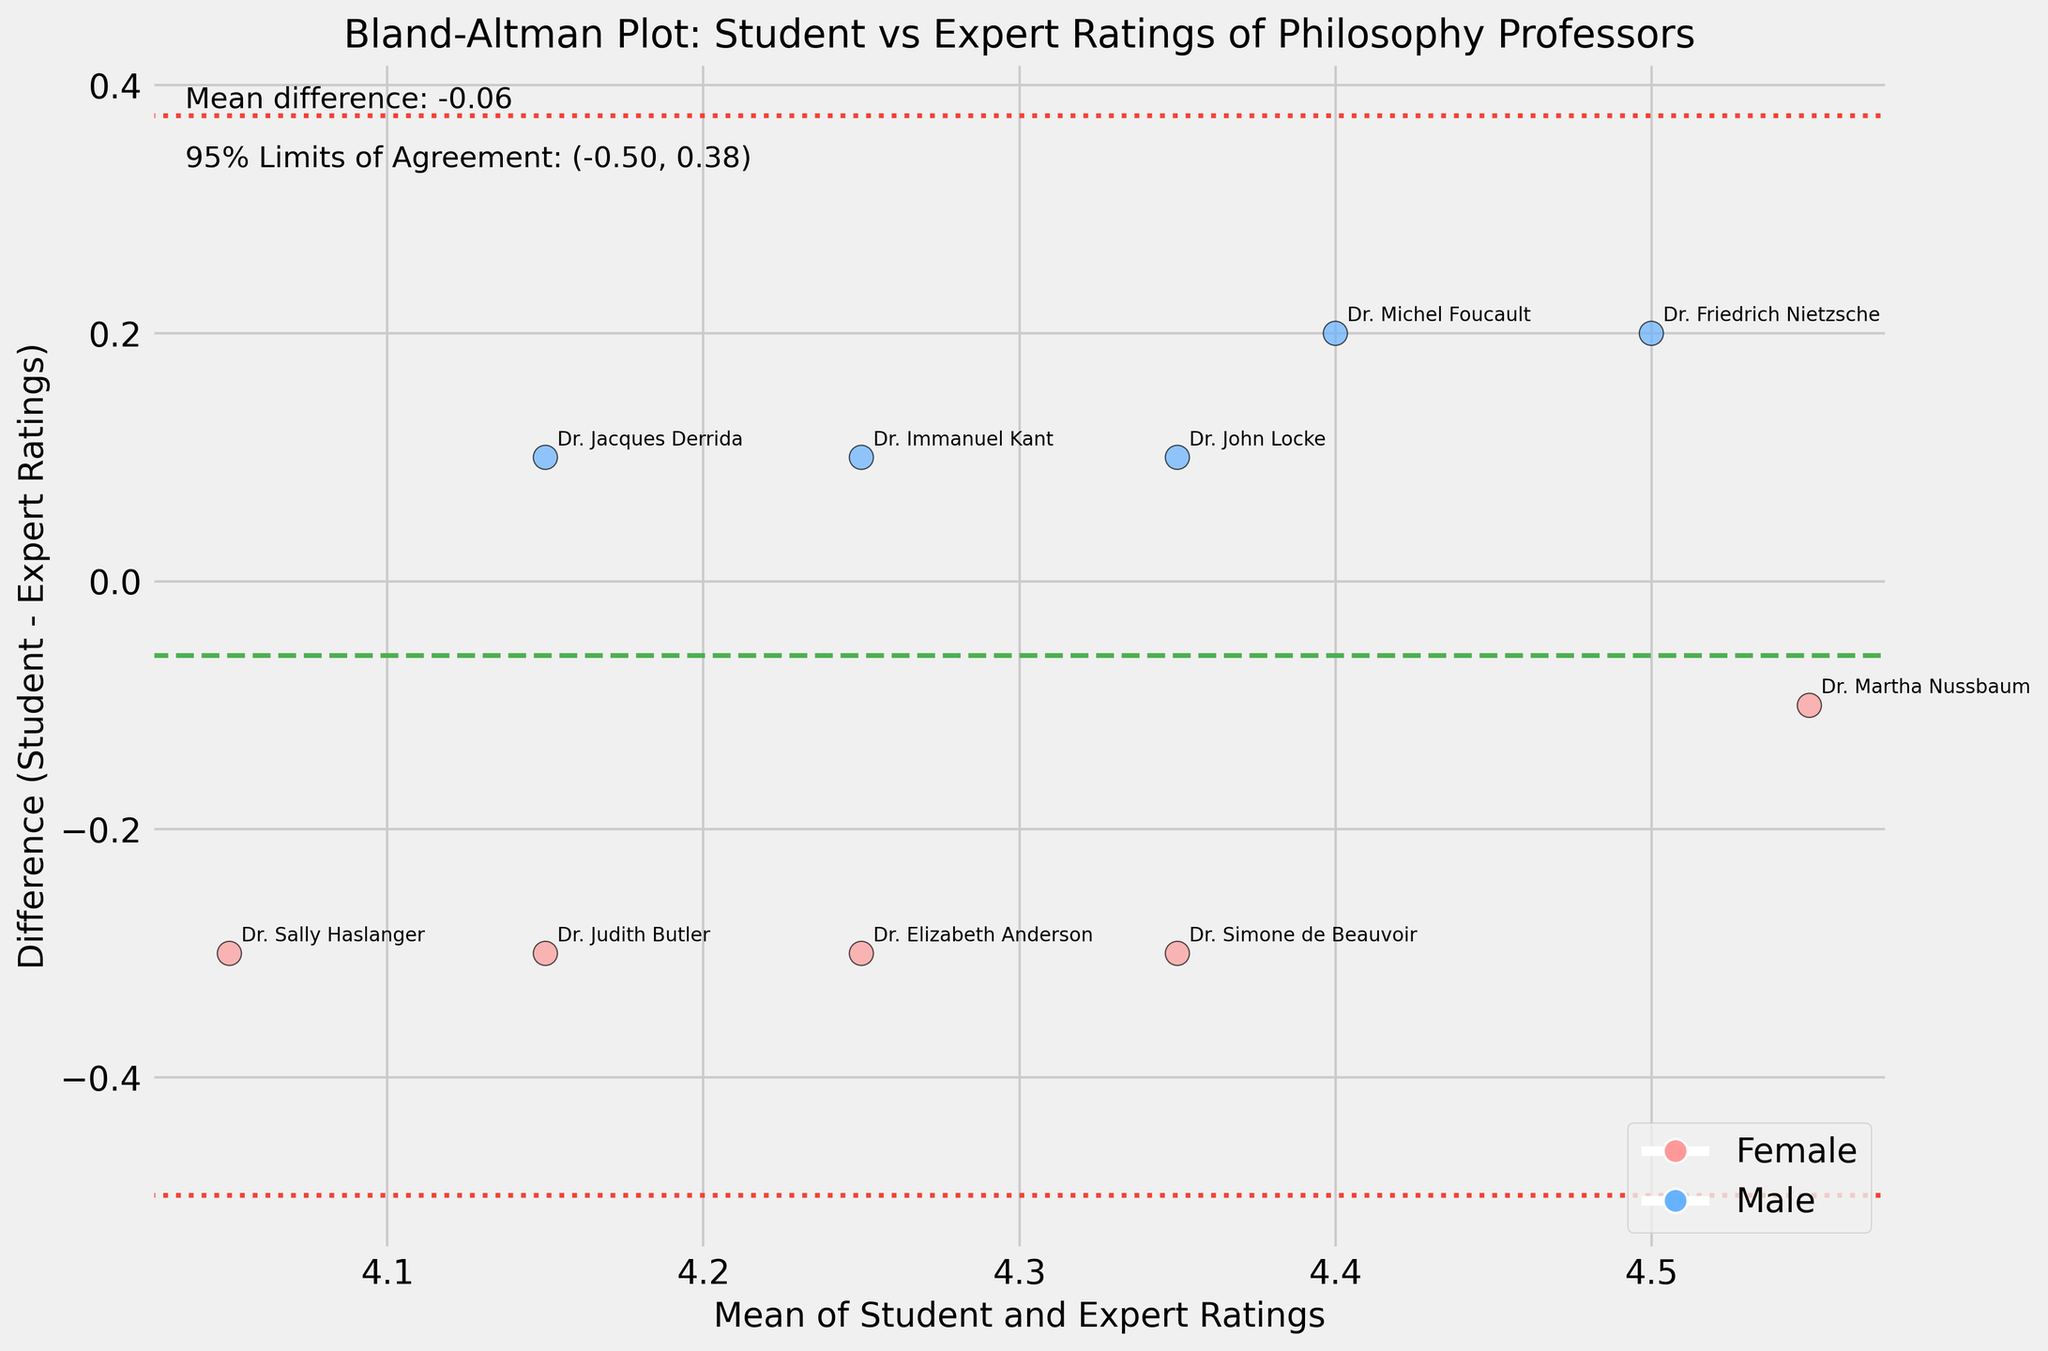What is the title of the plot? The title is displayed at the top center of the plot. It reads: "Bland-Altman Plot: Student vs Expert Ratings of Philosophy Professors".
Answer: Bland-Altman Plot: Student vs Expert Ratings of Philosophy Professors How many data points are displayed in the plot? Each data point represents an instructor. There are 10 distinct scatter points, each labeled with an instructor's name.
Answer: 10 What color represents female instructors in the plot? The scatter points for female instructors are colored in a light red (pink) shade, as indicated by the legend.
Answer: Pink Which instructor has the smallest difference between student and expert ratings? The smallest difference can be found by looking for the data point closest to the zero horizontal (mean difference) line. Dr. Martha Nussbaum (Female) has a difference close to zero.
Answer: Dr. Martha Nussbaum What is the mean difference between student and expert ratings? The mean difference is indicated by the horizontal dashed green line, labeled as "Mean difference: 0.10" in the text on the plot.
Answer: 0.10 Which instructor has the largest positive difference between student and expert ratings? The largest positive difference is found by locating the data point farthest above the zero line. Dr. Friedrich Nietzsche (Male) has the largest positive difference.
Answer: Dr. Friedrich Nietzsche What are the 95% limits of agreement in the plot? The dashed red lines and the text on the plot label the 95% limits of agreement. They are indicated as (-0.21, 0.41).
Answer: (-0.21, 0.41) Which gender has more instructors above the mean difference line? By counting the scatter points above the green mean difference line, you can see that the majority are blue, indicating male instructors.
Answer: Male What is the average of the mean ratings for Dr. Friedrich Nietzsche and Dr. Judith Butler? Mean ratings are calculated as the average of student and expert ratings. For Dr. Friedrich Nietzsche, it's (4.6 + 4.4)/2 = 4.5. For Dr. Judith Butler, it's (4.0 + 4.3)/2 = 4.15. The average of these is (4.5 + 4.15)/2 = 4.325.
Answer: 4.325 How does Dr. Sally Haslanger's difference in ratings compare to Dr. Jacques Derrida's? Dr. Sally Haslanger's difference is negative and greater in magnitude than Dr. Jacques Derrida's, which is closer to zero but also negative.
Answer: Greater (negative) 